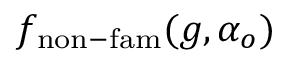Convert formula to latex. <formula><loc_0><loc_0><loc_500><loc_500>f _ { n o n - f a m } ( g , \alpha _ { o } )</formula> 